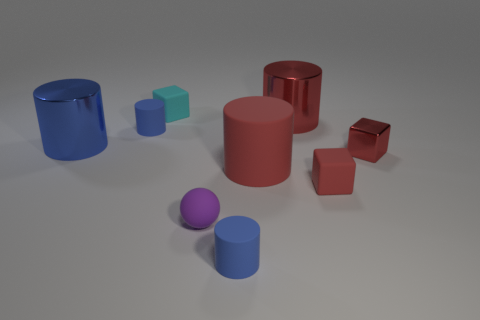How many things are either small spheres or tiny shiny cubes?
Offer a very short reply. 2. Does the rubber sphere have the same color as the big rubber cylinder?
Your answer should be very brief. No. Are there any other things that have the same size as the blue shiny cylinder?
Make the answer very short. Yes. There is a matte thing behind the blue rubber thing that is behind the shiny block; what is its shape?
Offer a very short reply. Cube. Is the number of tiny matte cylinders less than the number of tiny red metal balls?
Keep it short and to the point. No. There is a matte thing that is both in front of the red metallic cylinder and behind the big rubber cylinder; how big is it?
Your answer should be compact. Small. Does the rubber sphere have the same size as the blue metal object?
Offer a terse response. No. Does the big metal object left of the red metallic cylinder have the same color as the small ball?
Keep it short and to the point. No. What number of large objects are on the right side of the large matte object?
Make the answer very short. 1. Are there more shiny cylinders than small red matte things?
Provide a succinct answer. Yes. 